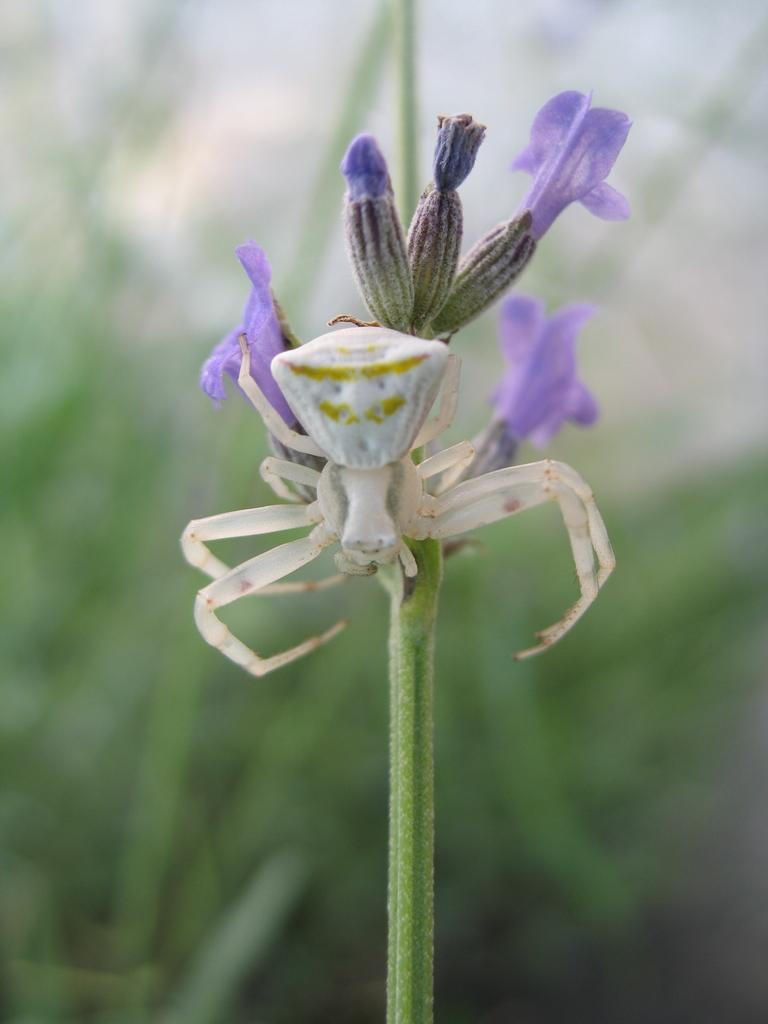What type of plants are in the image? There are flowers in the image. What part of the flowers can be seen in the image? The flowers have stems in the image. Is there any other living organism present on the flowers? Yes, there is a spider on one of the flowers. What type of fowl can be seen wearing a stocking on one of the flowers in the image? There is no fowl or stocking present on the flowers in the image. 